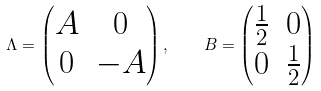Convert formula to latex. <formula><loc_0><loc_0><loc_500><loc_500>\Lambda = \left ( \begin{matrix} A & 0 \\ 0 & - A \end{matrix} \right ) , \quad B = \left ( \begin{matrix} \frac { 1 } { 2 } & 0 \\ 0 & \frac { 1 } { 2 } \end{matrix} \right )</formula> 